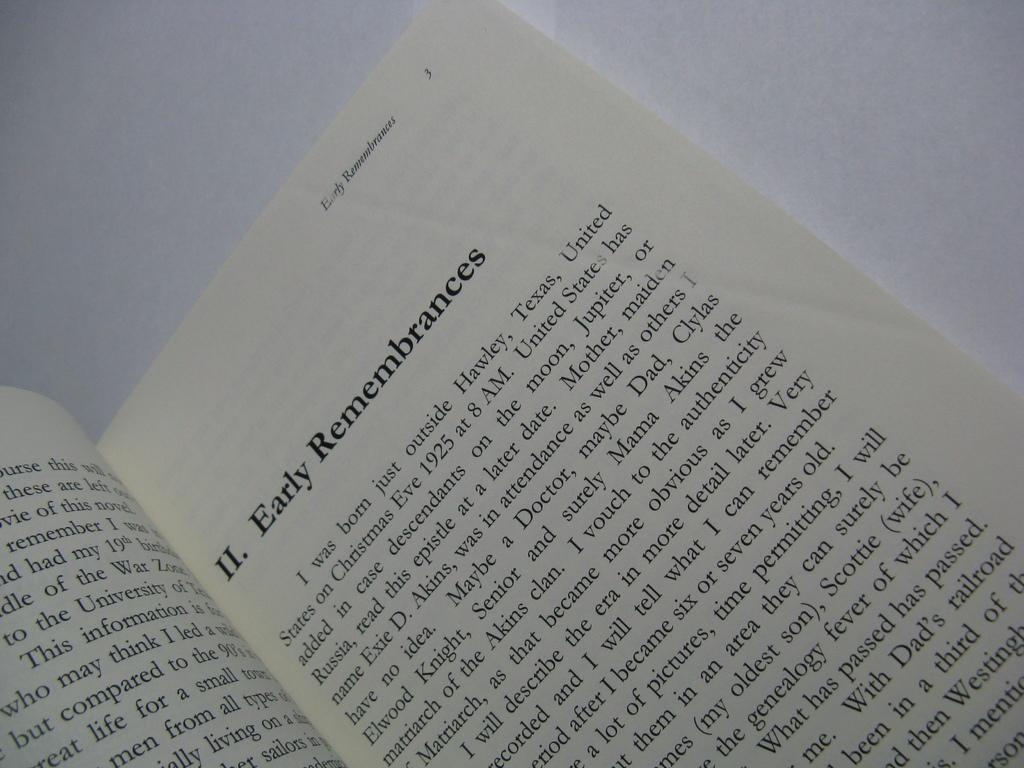<image>
Offer a succinct explanation of the picture presented. A particular section of a book marked with the Roman numeral II is titled Early Remembrances. 